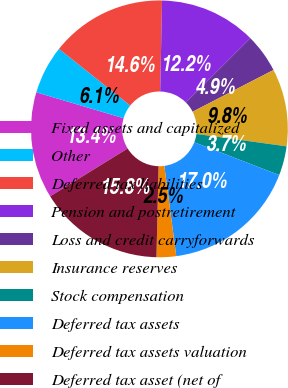Convert chart. <chart><loc_0><loc_0><loc_500><loc_500><pie_chart><fcel>Fixed assets and capitalized<fcel>Other<fcel>Deferred tax liabilities<fcel>Pension and postretirement<fcel>Loss and credit carryforwards<fcel>Insurance reserves<fcel>Stock compensation<fcel>Deferred tax assets<fcel>Deferred tax assets valuation<fcel>Deferred tax asset (net of<nl><fcel>13.4%<fcel>6.11%<fcel>14.62%<fcel>12.19%<fcel>4.9%<fcel>9.76%<fcel>3.68%<fcel>17.05%<fcel>2.46%<fcel>15.83%<nl></chart> 